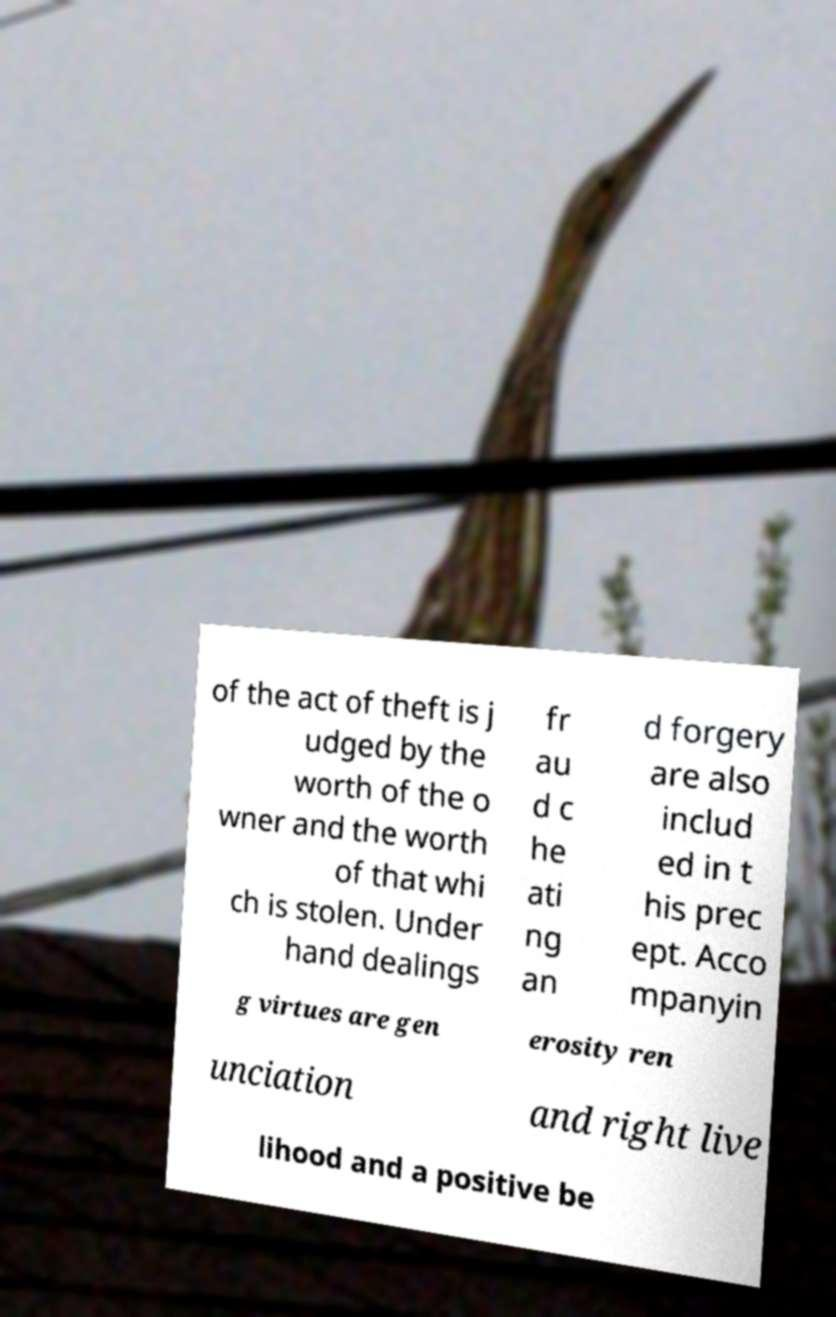Please identify and transcribe the text found in this image. of the act of theft is j udged by the worth of the o wner and the worth of that whi ch is stolen. Under hand dealings fr au d c he ati ng an d forgery are also includ ed in t his prec ept. Acco mpanyin g virtues are gen erosity ren unciation and right live lihood and a positive be 